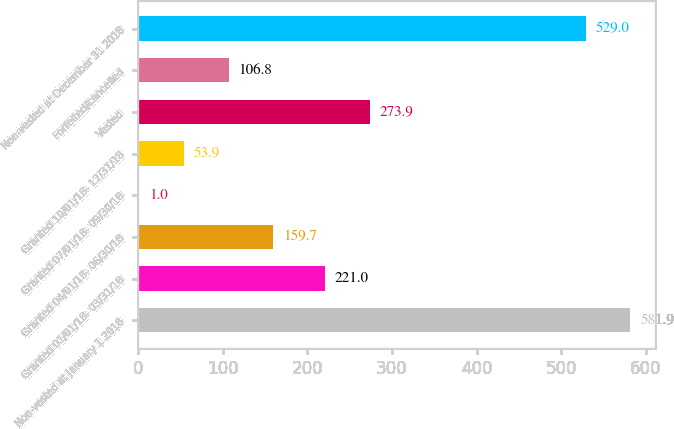Convert chart. <chart><loc_0><loc_0><loc_500><loc_500><bar_chart><fcel>Non-vested at January 1 2018<fcel>Granted 01/01/18- 03/31/18<fcel>Granted 04/01/18- 06/30/18<fcel>Granted 07/01/18- 09/30/18<fcel>Granted 10/01/18- 12/31/18<fcel>Vested<fcel>Forfeited/cancelled<fcel>Non-vested at December 31 2018<nl><fcel>581.9<fcel>221<fcel>159.7<fcel>1<fcel>53.9<fcel>273.9<fcel>106.8<fcel>529<nl></chart> 